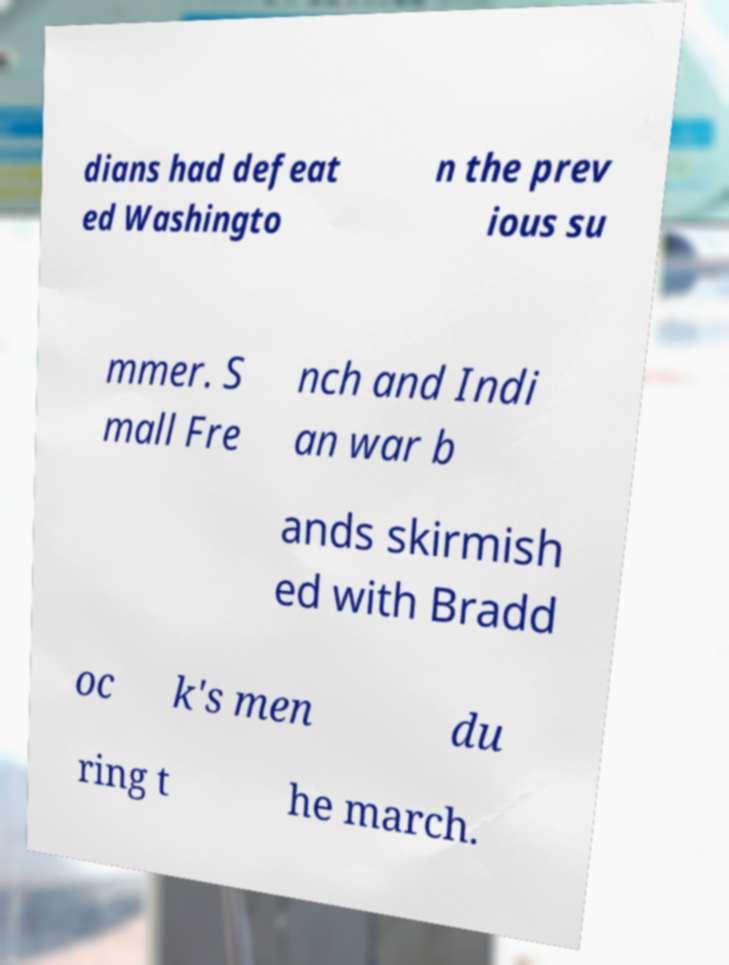There's text embedded in this image that I need extracted. Can you transcribe it verbatim? dians had defeat ed Washingto n the prev ious su mmer. S mall Fre nch and Indi an war b ands skirmish ed with Bradd oc k's men du ring t he march. 